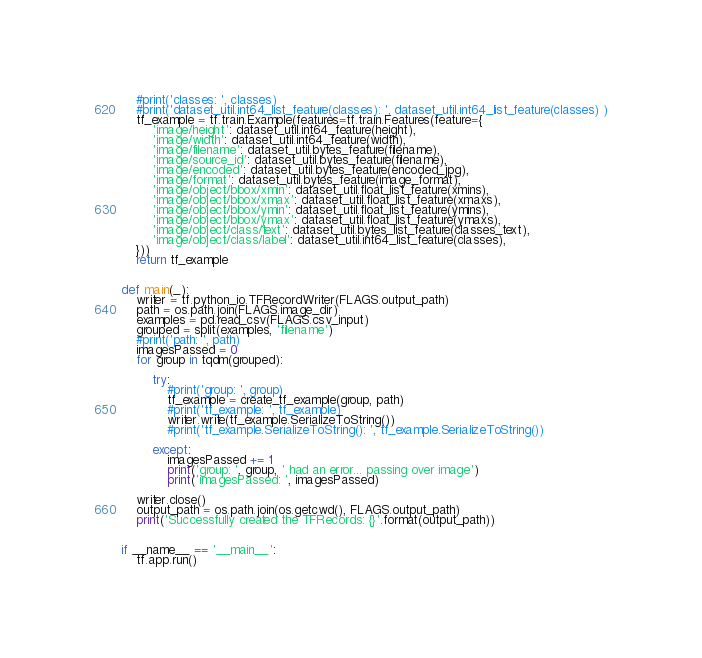<code> <loc_0><loc_0><loc_500><loc_500><_Python_>    #print('classes: ', classes)
    #print('dataset_util.int64_list_feature(classes): ', dataset_util.int64_list_feature(classes) )
    tf_example = tf.train.Example(features=tf.train.Features(feature={
        'image/height': dataset_util.int64_feature(height),
        'image/width': dataset_util.int64_feature(width),
        'image/filename': dataset_util.bytes_feature(filename),
        'image/source_id': dataset_util.bytes_feature(filename),
        'image/encoded': dataset_util.bytes_feature(encoded_jpg),
        'image/format': dataset_util.bytes_feature(image_format),
        'image/object/bbox/xmin': dataset_util.float_list_feature(xmins),
        'image/object/bbox/xmax': dataset_util.float_list_feature(xmaxs),
        'image/object/bbox/ymin': dataset_util.float_list_feature(ymins),
        'image/object/bbox/ymax': dataset_util.float_list_feature(ymaxs),
        'image/object/class/text': dataset_util.bytes_list_feature(classes_text),
        'image/object/class/label': dataset_util.int64_list_feature(classes),
    }))
    return tf_example


def main(_):
    writer = tf.python_io.TFRecordWriter(FLAGS.output_path)
    path = os.path.join(FLAGS.image_dir)
    examples = pd.read_csv(FLAGS.csv_input)
    grouped = split(examples, 'filename')
    #print('path: ', path)
    imagesPassed = 0
    for group in tqdm(grouped):
        
        try:
            #print('group: ', group)
            tf_example = create_tf_example(group, path)
            #print('tf_example: ', tf_example)
            writer.write(tf_example.SerializeToString())
            #print('tf_example.SerializeToString(): ', tf_example.SerializeToString())
            
        except:
            imagesPassed += 1
            print('group: ', group, ' had an error... passing over image')
            print('imagesPassed: ', imagesPassed)
        
    writer.close()
    output_path = os.path.join(os.getcwd(), FLAGS.output_path)
    print('Successfully created the TFRecords: {}'.format(output_path))


if __name__ == '__main__':
    tf.app.run()
</code> 